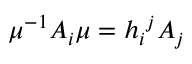Convert formula to latex. <formula><loc_0><loc_0><loc_500><loc_500>\mu ^ { - 1 } A _ { i } \mu = h _ { i ^ { j } A _ { j }</formula> 